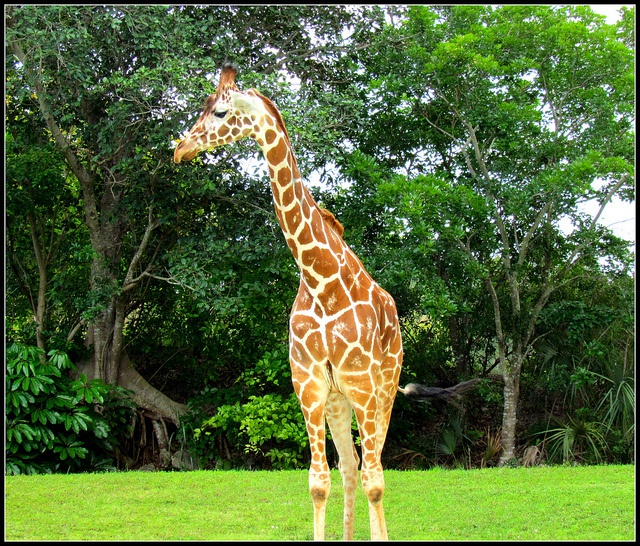Describe the objects in this image and their specific colors. I can see a giraffe in black, beige, khaki, tan, and red tones in this image. 